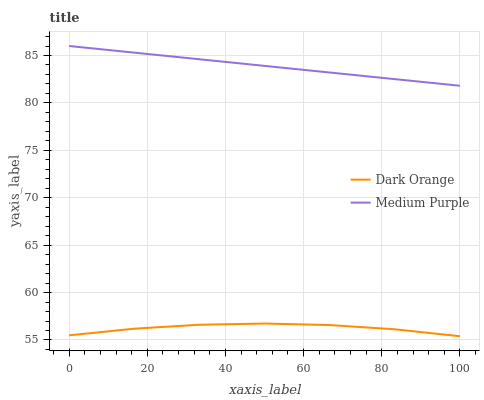Does Dark Orange have the minimum area under the curve?
Answer yes or no. Yes. Does Medium Purple have the maximum area under the curve?
Answer yes or no. Yes. Does Dark Orange have the maximum area under the curve?
Answer yes or no. No. Is Medium Purple the smoothest?
Answer yes or no. Yes. Is Dark Orange the roughest?
Answer yes or no. Yes. Is Dark Orange the smoothest?
Answer yes or no. No. Does Dark Orange have the lowest value?
Answer yes or no. Yes. Does Medium Purple have the highest value?
Answer yes or no. Yes. Does Dark Orange have the highest value?
Answer yes or no. No. Is Dark Orange less than Medium Purple?
Answer yes or no. Yes. Is Medium Purple greater than Dark Orange?
Answer yes or no. Yes. Does Dark Orange intersect Medium Purple?
Answer yes or no. No. 